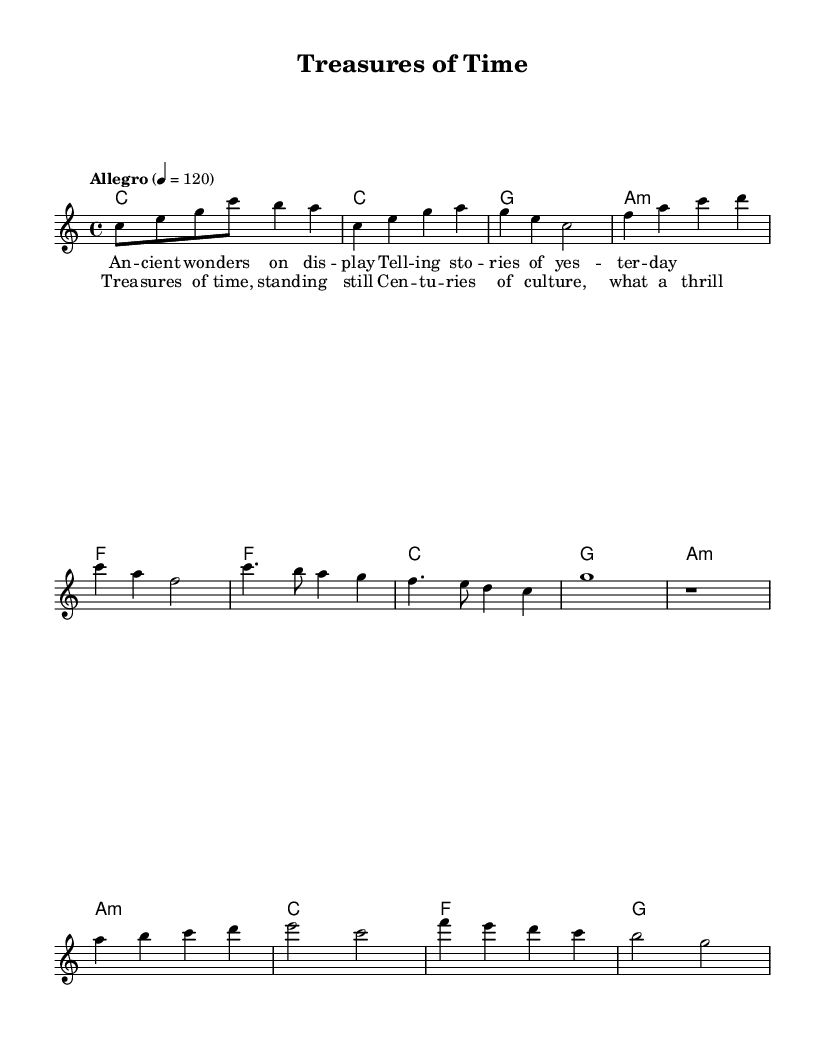What is the key signature of this music? The key signature is C major, which is indicated at the beginning of the score and has no sharps or flats.
Answer: C major What is the time signature of this music? The time signature is shown at the start of the score, represented as 4/4, meaning there are four beats in a measure.
Answer: 4/4 What is the tempo marking for this piece? The tempo marking is specified in the score as "Allegro" with a metronome marking of 120 beats per minute, indicating a fast pace.
Answer: Allegro, 120 How many measures are in the verse section? By counting the measures in the verse from the printed score, there are four measures present in the verse section.
Answer: 4 measures What is the structure of the song? The song has an Intro, Verse, Chorus, and Bridge sections, which can be seen organized in the score.
Answer: Intro, Verse, Chorus, Bridge What type of chords are predominantly used in the verse? The verse primarily utilizes major and minor chords such as C major, G major, A minor, and F major as indicated in the chord symbols.
Answer: Major and minor chords How does the chorus melody compare to the verse melody? The chorus melody uses a higher pitch range and has a more pronounced rhythmic pattern than the verse melody, emphasizing its uplifting character typical of Pop.
Answer: Higher pitch, pronounced rhythm 